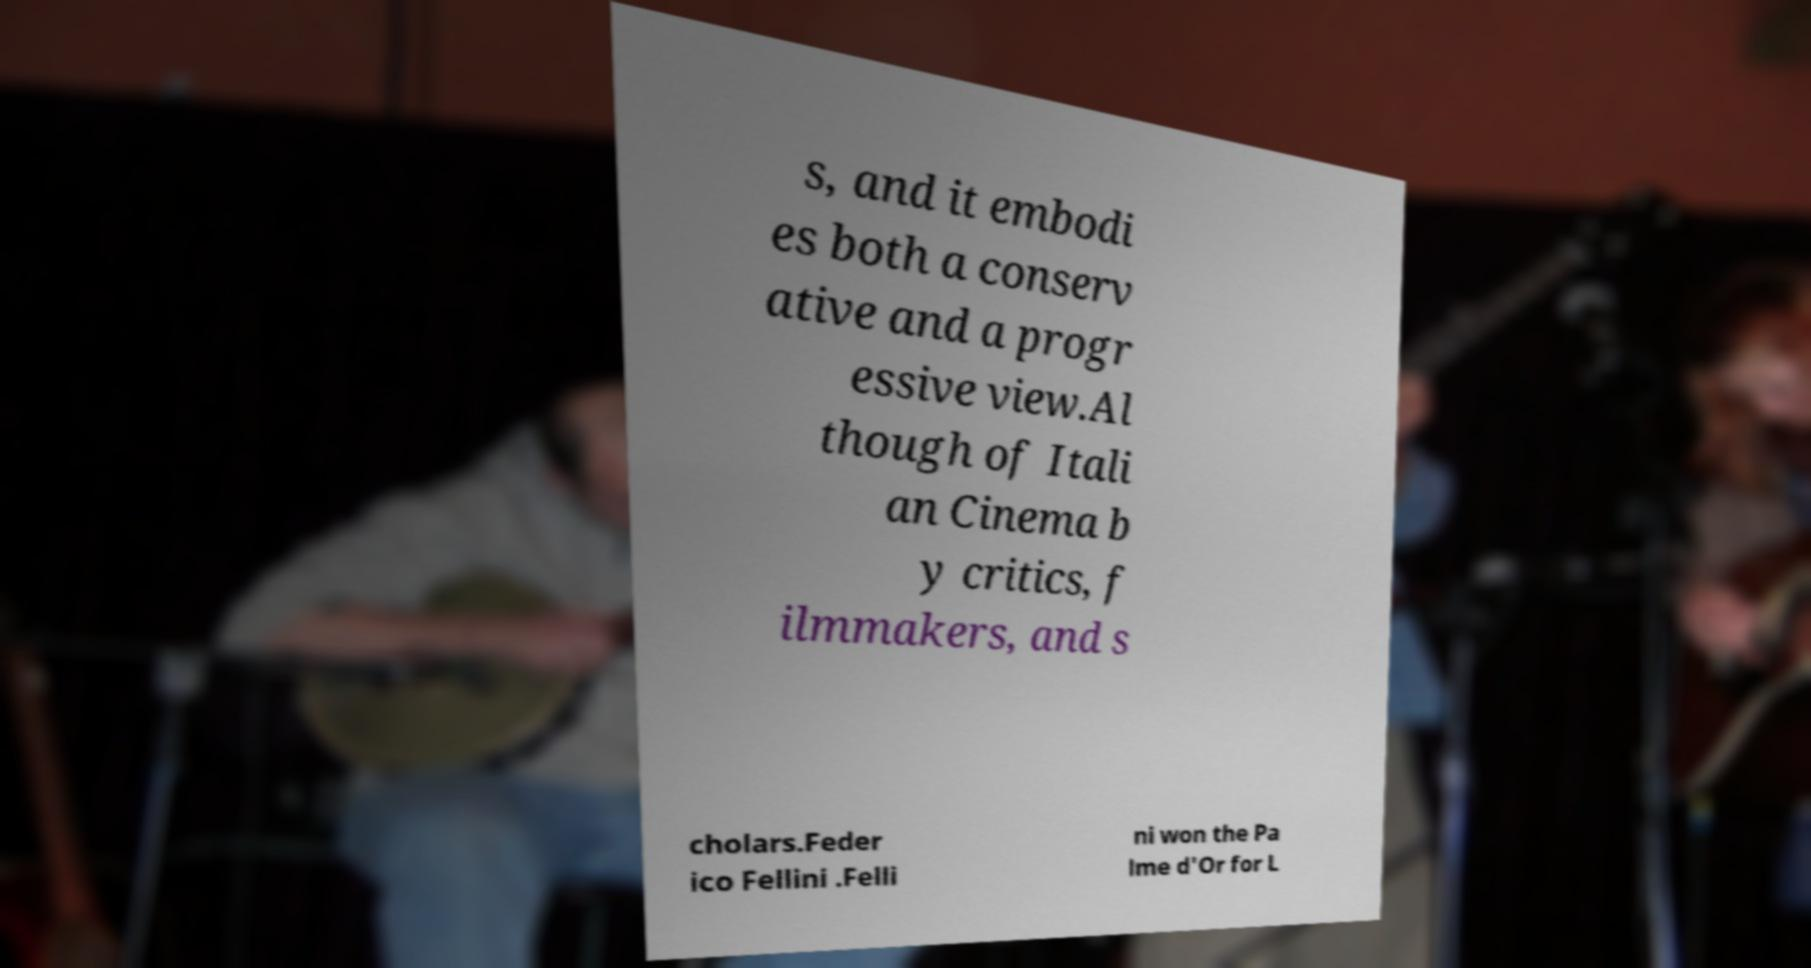I need the written content from this picture converted into text. Can you do that? s, and it embodi es both a conserv ative and a progr essive view.Al though of Itali an Cinema b y critics, f ilmmakers, and s cholars.Feder ico Fellini .Felli ni won the Pa lme d'Or for L 